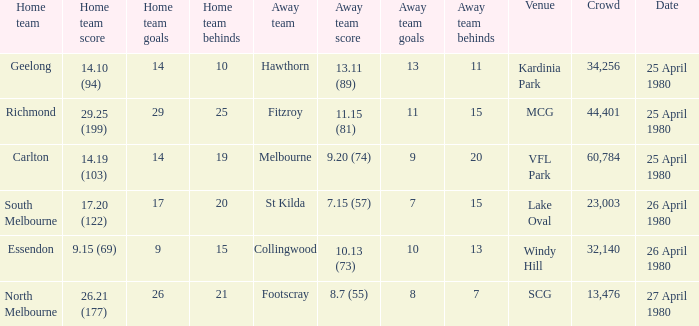What wa the date of the North Melbourne home game? 27 April 1980. 